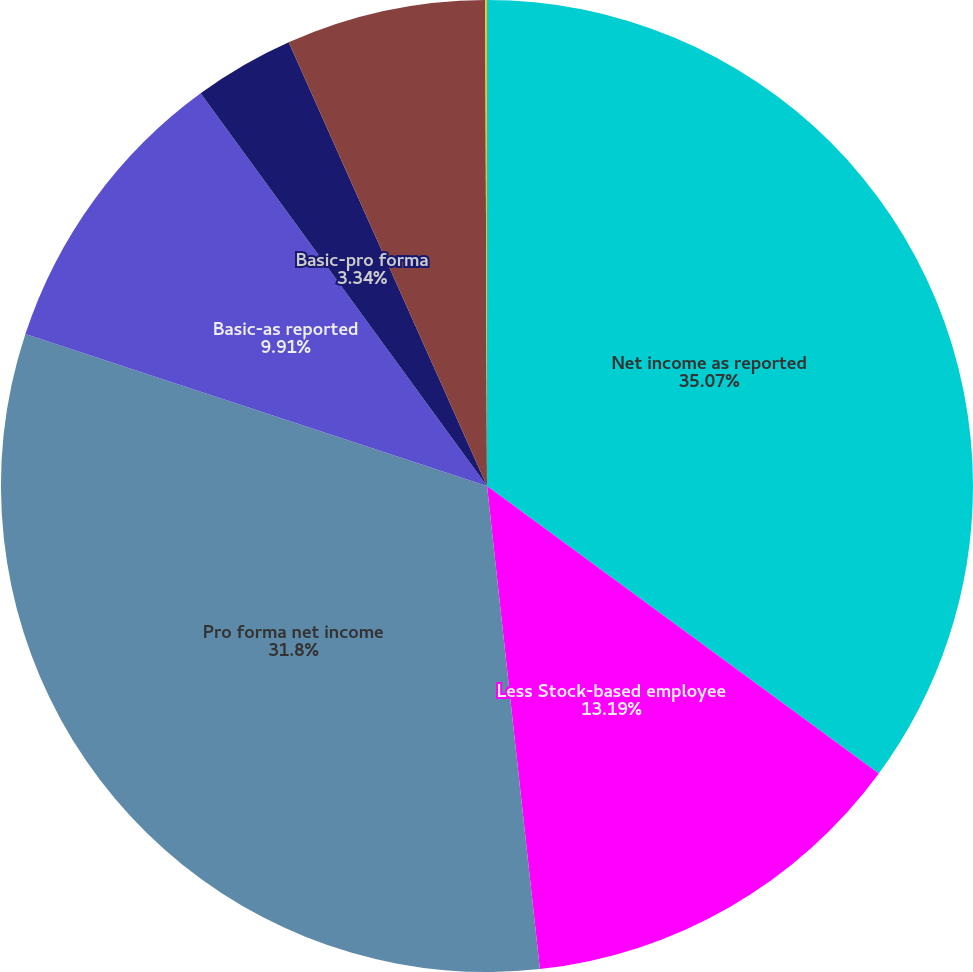Convert chart to OTSL. <chart><loc_0><loc_0><loc_500><loc_500><pie_chart><fcel>Net income as reported<fcel>Less Stock-based employee<fcel>Pro forma net income<fcel>Basic-as reported<fcel>Basic-pro forma<fcel>Diluted-as reported<fcel>Diluted-pro forma<nl><fcel>35.08%<fcel>13.19%<fcel>31.8%<fcel>9.91%<fcel>3.34%<fcel>6.63%<fcel>0.06%<nl></chart> 